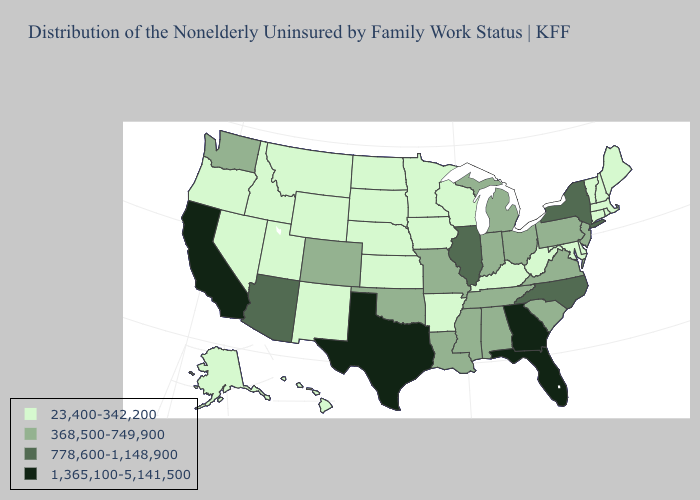What is the value of Colorado?
Short answer required. 368,500-749,900. Name the states that have a value in the range 368,500-749,900?
Be succinct. Alabama, Colorado, Indiana, Louisiana, Michigan, Mississippi, Missouri, New Jersey, Ohio, Oklahoma, Pennsylvania, South Carolina, Tennessee, Virginia, Washington. Among the states that border Georgia , which have the lowest value?
Be succinct. Alabama, South Carolina, Tennessee. Which states have the lowest value in the USA?
Keep it brief. Alaska, Arkansas, Connecticut, Delaware, Hawaii, Idaho, Iowa, Kansas, Kentucky, Maine, Maryland, Massachusetts, Minnesota, Montana, Nebraska, Nevada, New Hampshire, New Mexico, North Dakota, Oregon, Rhode Island, South Dakota, Utah, Vermont, West Virginia, Wisconsin, Wyoming. Does Iowa have the lowest value in the MidWest?
Answer briefly. Yes. What is the lowest value in the South?
Answer briefly. 23,400-342,200. What is the value of Nevada?
Write a very short answer. 23,400-342,200. Does Utah have the lowest value in the USA?
Short answer required. Yes. Which states have the lowest value in the USA?
Be succinct. Alaska, Arkansas, Connecticut, Delaware, Hawaii, Idaho, Iowa, Kansas, Kentucky, Maine, Maryland, Massachusetts, Minnesota, Montana, Nebraska, Nevada, New Hampshire, New Mexico, North Dakota, Oregon, Rhode Island, South Dakota, Utah, Vermont, West Virginia, Wisconsin, Wyoming. What is the highest value in states that border Kentucky?
Concise answer only. 778,600-1,148,900. Does Alabama have the lowest value in the USA?
Concise answer only. No. Name the states that have a value in the range 368,500-749,900?
Quick response, please. Alabama, Colorado, Indiana, Louisiana, Michigan, Mississippi, Missouri, New Jersey, Ohio, Oklahoma, Pennsylvania, South Carolina, Tennessee, Virginia, Washington. Does the first symbol in the legend represent the smallest category?
Be succinct. Yes. Does California have the highest value in the West?
Write a very short answer. Yes. How many symbols are there in the legend?
Concise answer only. 4. 